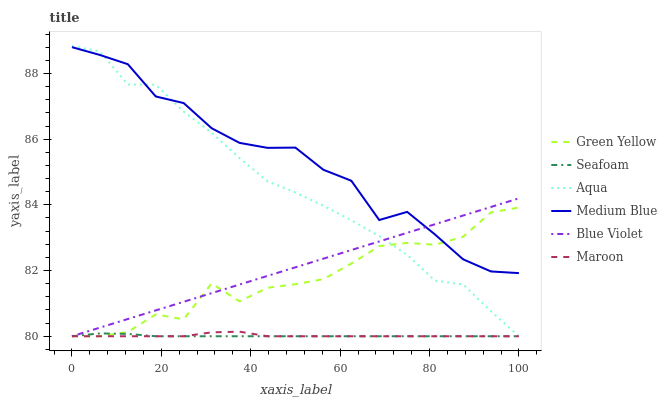Does Seafoam have the minimum area under the curve?
Answer yes or no. Yes. Does Medium Blue have the maximum area under the curve?
Answer yes or no. Yes. Does Medium Blue have the minimum area under the curve?
Answer yes or no. No. Does Seafoam have the maximum area under the curve?
Answer yes or no. No. Is Blue Violet the smoothest?
Answer yes or no. Yes. Is Medium Blue the roughest?
Answer yes or no. Yes. Is Seafoam the smoothest?
Answer yes or no. No. Is Seafoam the roughest?
Answer yes or no. No. Does Aqua have the lowest value?
Answer yes or no. Yes. Does Medium Blue have the lowest value?
Answer yes or no. No. Does Aqua have the highest value?
Answer yes or no. Yes. Does Medium Blue have the highest value?
Answer yes or no. No. Is Seafoam less than Medium Blue?
Answer yes or no. Yes. Is Medium Blue greater than Seafoam?
Answer yes or no. Yes. Does Blue Violet intersect Seafoam?
Answer yes or no. Yes. Is Blue Violet less than Seafoam?
Answer yes or no. No. Is Blue Violet greater than Seafoam?
Answer yes or no. No. Does Seafoam intersect Medium Blue?
Answer yes or no. No. 